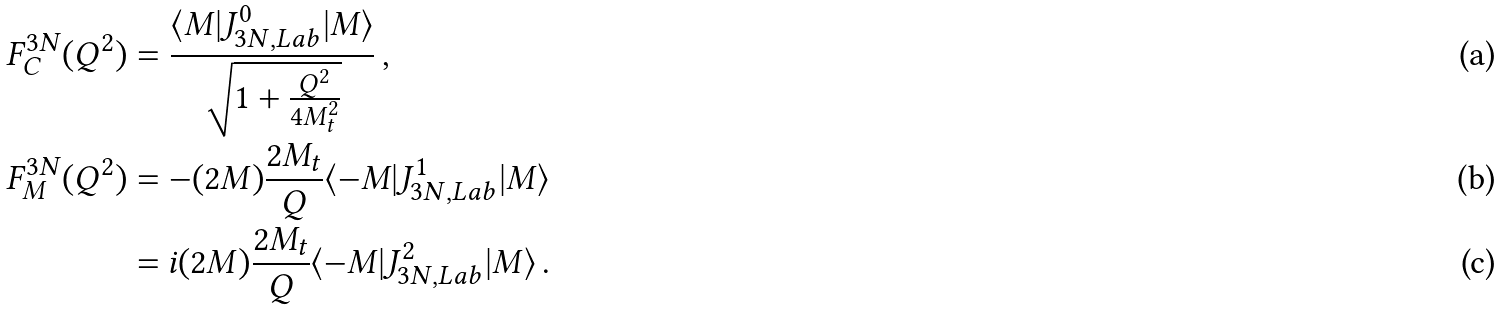Convert formula to latex. <formula><loc_0><loc_0><loc_500><loc_500>F ^ { 3 N } _ { C } ( Q ^ { 2 } ) & = \frac { \langle M | J ^ { 0 } _ { 3 N , L a b } | M \rangle } { \sqrt { 1 + \frac { Q ^ { 2 } } { 4 M _ { t } ^ { 2 } } } } \, , \\ F ^ { 3 N } _ { M } ( Q ^ { 2 } ) & = - ( 2 M ) \frac { 2 M _ { t } } { Q } \langle - M | J ^ { 1 } _ { 3 N , L a b } | M \rangle \\ & = i ( 2 M ) \frac { 2 M _ { t } } { Q } \langle - M | J ^ { 2 } _ { 3 N , L a b } | M \rangle \, .</formula> 